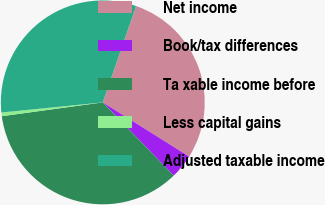<chart> <loc_0><loc_0><loc_500><loc_500><pie_chart><fcel>Net income<fcel>Book/tax differences<fcel>Ta xable income before<fcel>Less capital gains<fcel>Adjusted taxable income<nl><fcel>28.62%<fcel>3.84%<fcel>35.07%<fcel>0.58%<fcel>31.88%<nl></chart> 